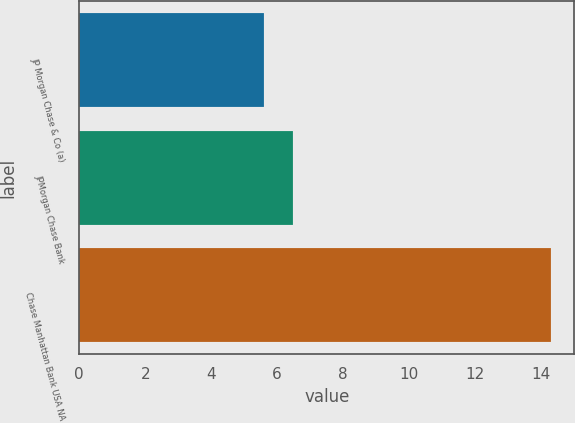<chart> <loc_0><loc_0><loc_500><loc_500><bar_chart><fcel>JP Morgan Chase & Co (a)<fcel>JPMorgan Chase Bank<fcel>Chase Manhattan Bank USA NA<nl><fcel>5.6<fcel>6.47<fcel>14.3<nl></chart> 